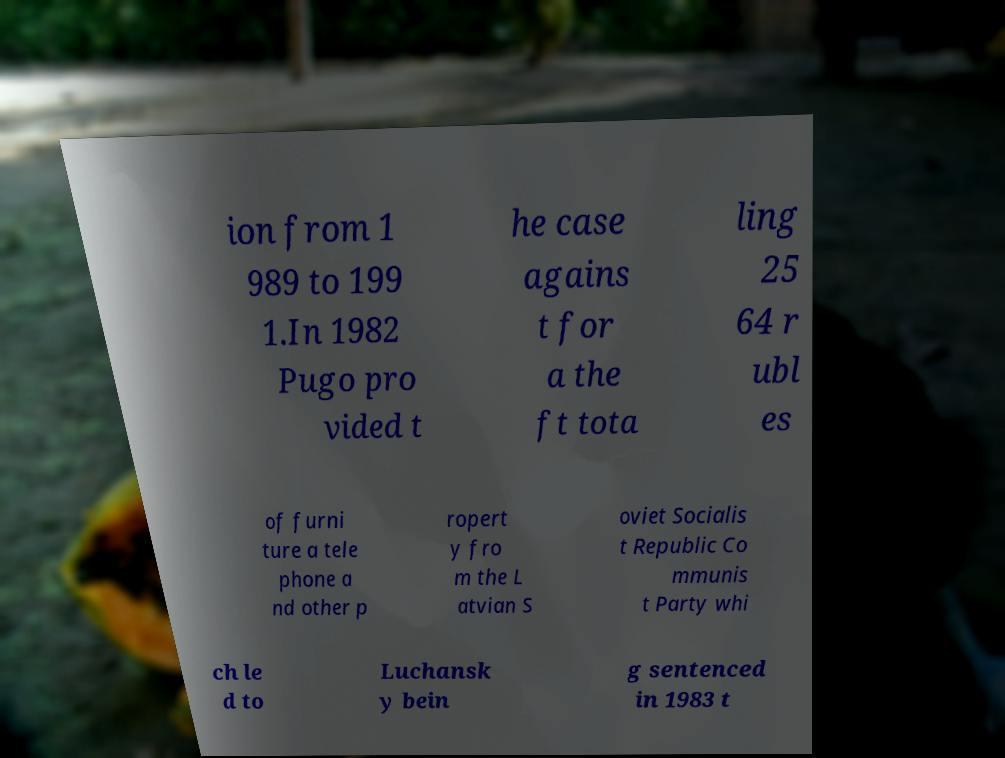There's text embedded in this image that I need extracted. Can you transcribe it verbatim? ion from 1 989 to 199 1.In 1982 Pugo pro vided t he case agains t for a the ft tota ling 25 64 r ubl es of furni ture a tele phone a nd other p ropert y fro m the L atvian S oviet Socialis t Republic Co mmunis t Party whi ch le d to Luchansk y bein g sentenced in 1983 t 